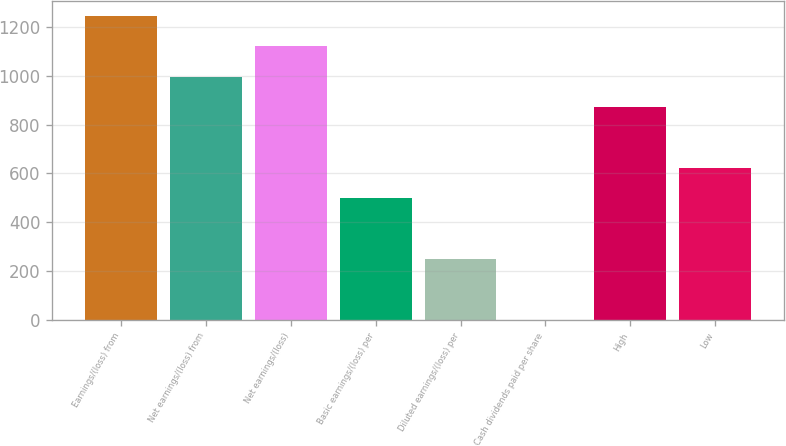<chart> <loc_0><loc_0><loc_500><loc_500><bar_chart><fcel>Earnings/(loss) from<fcel>Net earnings/(loss) from<fcel>Net earnings/(loss)<fcel>Basic earnings/(loss) per<fcel>Diluted earnings/(loss) per<fcel>Cash dividends paid per share<fcel>High<fcel>Low<nl><fcel>1247<fcel>997.68<fcel>1122.34<fcel>499.04<fcel>249.72<fcel>0.4<fcel>873.02<fcel>623.7<nl></chart> 